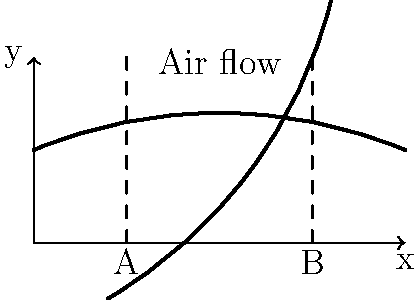As a music enthusiast exploring wind instruments, consider the simplified diagram of a wind instrument above. If the cross-sectional area at point A is 20 cm² and at point B is 15 cm², assuming incompressible flow, what is the ratio of air velocities at points B to A? To solve this problem, we'll use the principle of continuity for incompressible flow. Here's a step-by-step explanation:

1. The continuity equation for incompressible flow states that the volumetric flow rate is constant throughout the tube:

   $$Q = A_1v_1 = A_2v_2$$

   Where $Q$ is the volumetric flow rate, $A$ is the cross-sectional area, and $v$ is the velocity.

2. We're given:
   $A_A = 20$ cm²
   $A_B = 15$ cm²

3. Let's call the velocities at A and B $v_A$ and $v_B$ respectively. We can write:

   $$A_Av_A = A_Bv_B$$

4. To find the ratio of velocities, we can rearrange this equation:

   $$\frac{v_B}{v_A} = \frac{A_A}{A_B}$$

5. Now we can substitute the known values:

   $$\frac{v_B}{v_A} = \frac{20}{15}$$

6. Simplify the fraction:

   $$\frac{v_B}{v_A} = \frac{4}{3}$$

Therefore, the ratio of air velocities at point B to point A is 4:3 or 1.33:1.
Answer: 4:3 